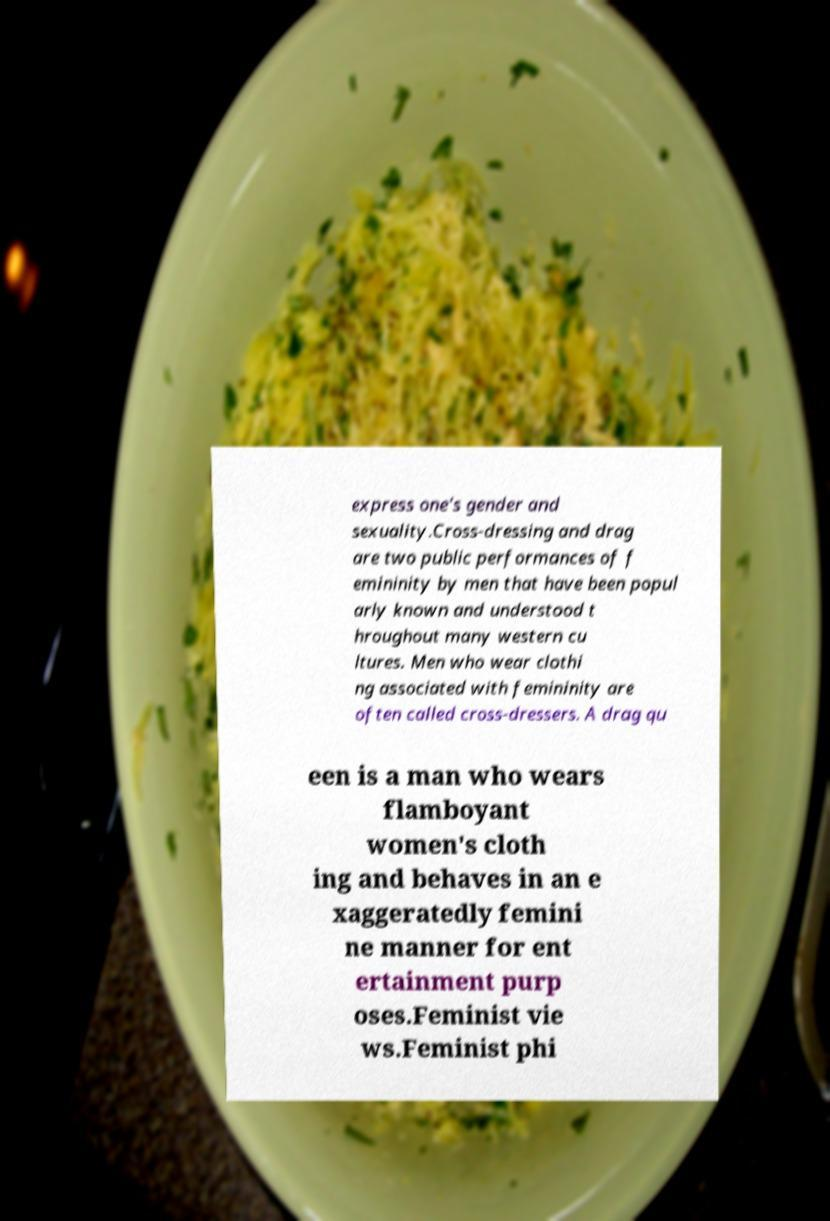What messages or text are displayed in this image? I need them in a readable, typed format. express one's gender and sexuality.Cross-dressing and drag are two public performances of f emininity by men that have been popul arly known and understood t hroughout many western cu ltures. Men who wear clothi ng associated with femininity are often called cross-dressers. A drag qu een is a man who wears flamboyant women's cloth ing and behaves in an e xaggeratedly femini ne manner for ent ertainment purp oses.Feminist vie ws.Feminist phi 